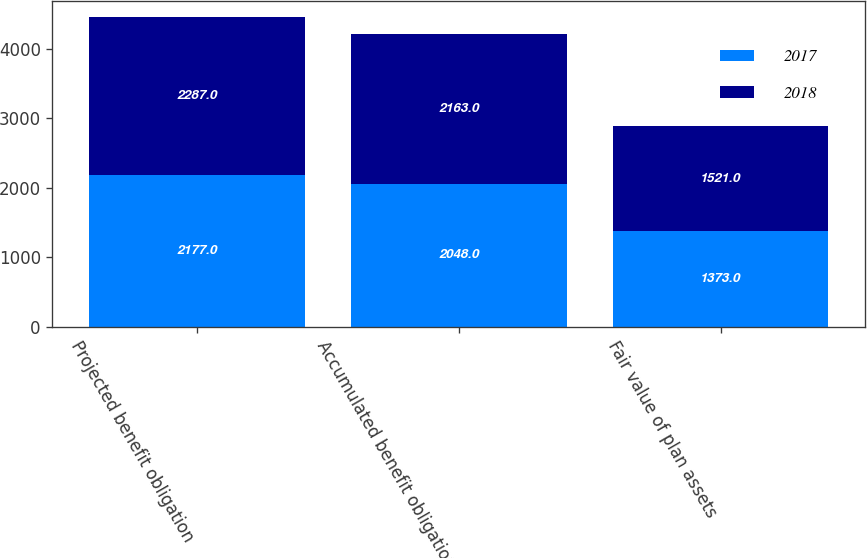<chart> <loc_0><loc_0><loc_500><loc_500><stacked_bar_chart><ecel><fcel>Projected benefit obligation<fcel>Accumulated benefit obligation<fcel>Fair value of plan assets<nl><fcel>2017<fcel>2177<fcel>2048<fcel>1373<nl><fcel>2018<fcel>2287<fcel>2163<fcel>1521<nl></chart> 